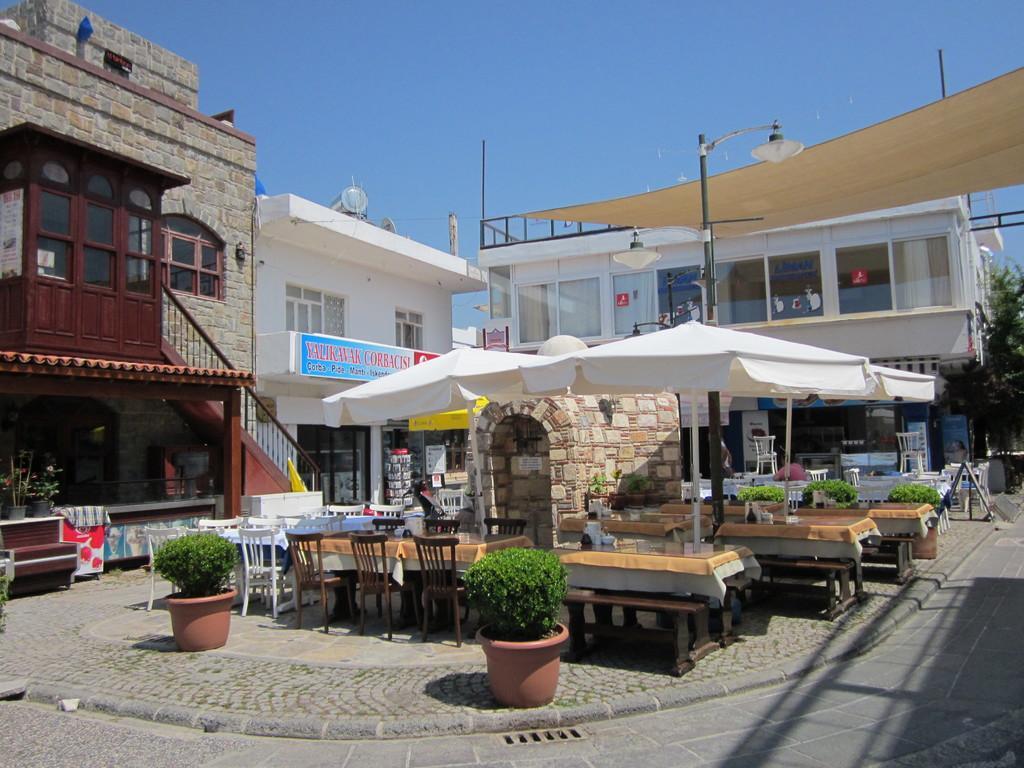Please provide a concise description of this image. In the image we can see there are buildings and there is tables and chairs and over it there is umbrella. 